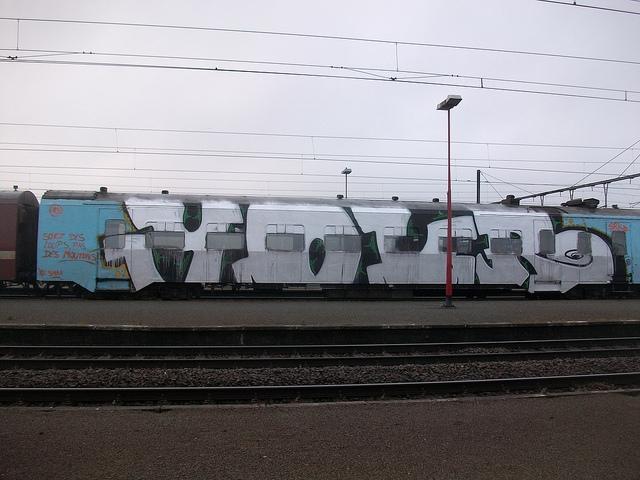How many sections of the tram car is there?
Give a very brief answer. 1. How many train tracks are visible?
Give a very brief answer. 2. How many cars are on the road?
Give a very brief answer. 0. How many people are standing on a white line?
Give a very brief answer. 0. 